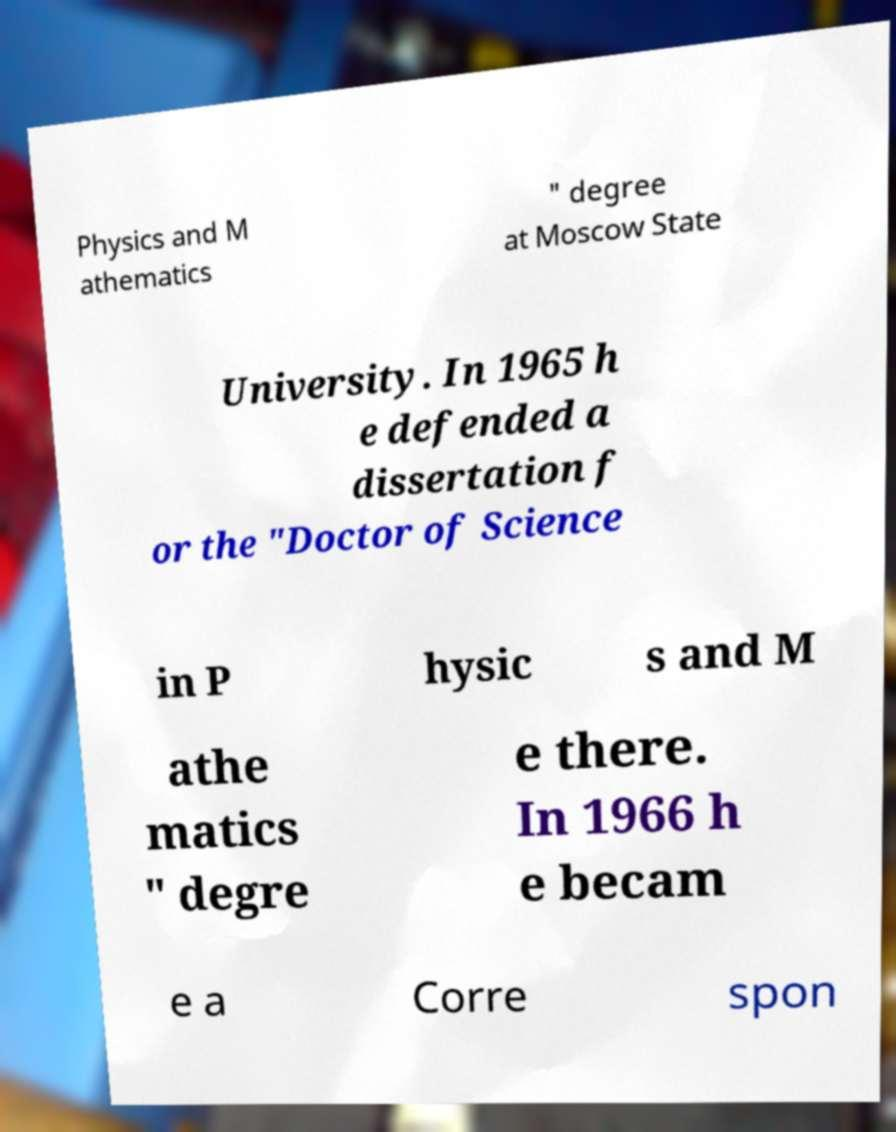For documentation purposes, I need the text within this image transcribed. Could you provide that? Physics and M athematics " degree at Moscow State University. In 1965 h e defended a dissertation f or the "Doctor of Science in P hysic s and M athe matics " degre e there. In 1966 h e becam e a Corre spon 